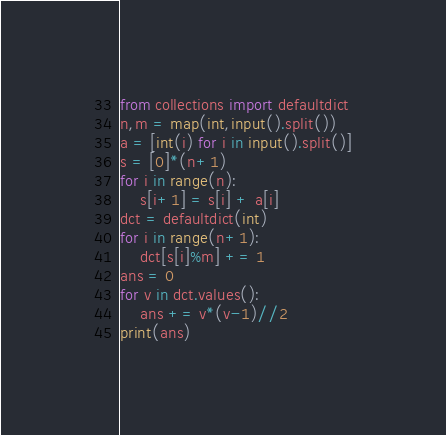<code> <loc_0><loc_0><loc_500><loc_500><_Python_>from collections import defaultdict
n,m = map(int,input().split())
a = [int(i) for i in input().split()]
s = [0]*(n+1)
for i in range(n):
    s[i+1] = s[i] + a[i]
dct = defaultdict(int)
for i in range(n+1):
    dct[s[i]%m] += 1
ans = 0
for v in dct.values():
    ans += v*(v-1)//2
print(ans)</code> 